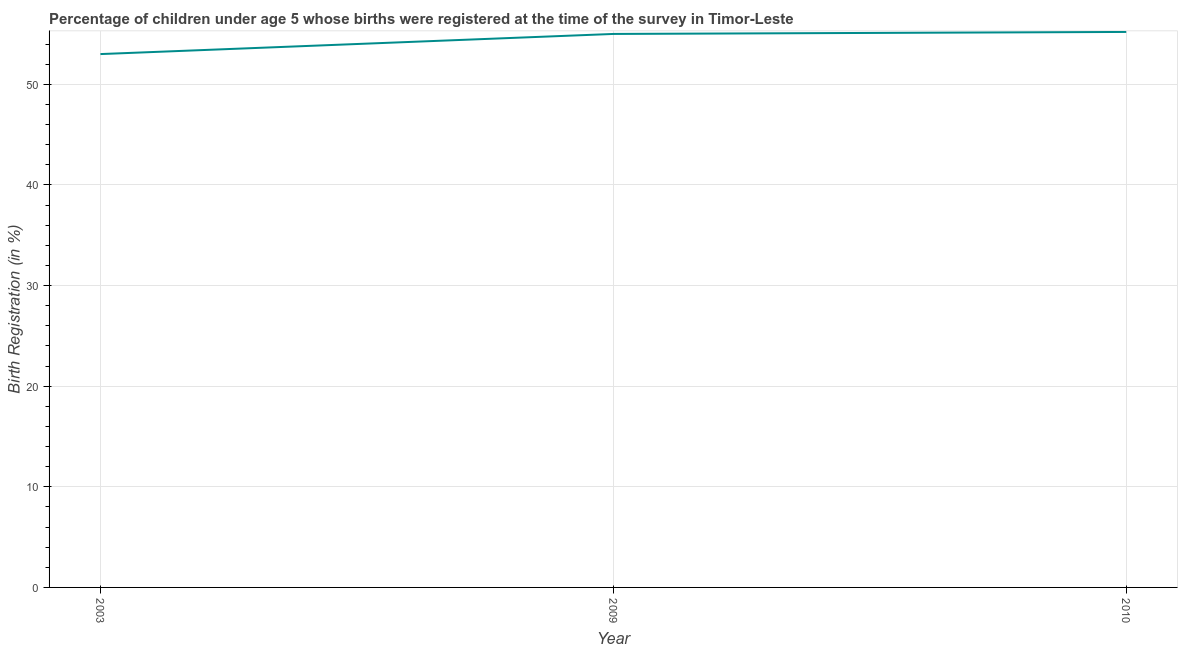Across all years, what is the maximum birth registration?
Your answer should be very brief. 55.2. In which year was the birth registration minimum?
Provide a short and direct response. 2003. What is the sum of the birth registration?
Offer a very short reply. 163.2. What is the difference between the birth registration in 2003 and 2010?
Give a very brief answer. -2.2. What is the average birth registration per year?
Offer a terse response. 54.4. Do a majority of the years between 2010 and 2003 (inclusive) have birth registration greater than 48 %?
Offer a terse response. No. What is the ratio of the birth registration in 2009 to that in 2010?
Offer a terse response. 1. Is the birth registration in 2003 less than that in 2009?
Your response must be concise. Yes. What is the difference between the highest and the second highest birth registration?
Offer a very short reply. 0.2. Is the sum of the birth registration in 2003 and 2009 greater than the maximum birth registration across all years?
Give a very brief answer. Yes. What is the difference between the highest and the lowest birth registration?
Offer a very short reply. 2.2. How many lines are there?
Ensure brevity in your answer.  1. What is the title of the graph?
Offer a terse response. Percentage of children under age 5 whose births were registered at the time of the survey in Timor-Leste. What is the label or title of the X-axis?
Keep it short and to the point. Year. What is the label or title of the Y-axis?
Offer a very short reply. Birth Registration (in %). What is the Birth Registration (in %) in 2010?
Ensure brevity in your answer.  55.2. What is the difference between the Birth Registration (in %) in 2003 and 2010?
Your response must be concise. -2.2. What is the difference between the Birth Registration (in %) in 2009 and 2010?
Keep it short and to the point. -0.2. What is the ratio of the Birth Registration (in %) in 2003 to that in 2009?
Your answer should be very brief. 0.96. What is the ratio of the Birth Registration (in %) in 2009 to that in 2010?
Your answer should be very brief. 1. 